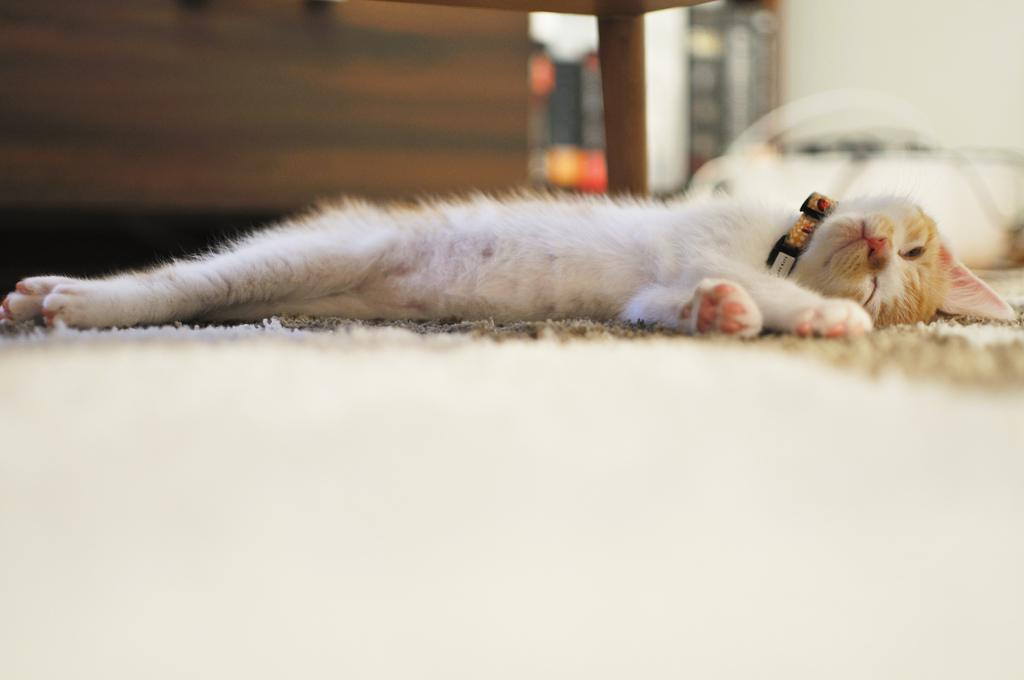What animal is present in the image? There is a cat in the image. What is the cat doing in the image? The cat is sleeping. Where is the cat located in the image? The cat is on a bed. How is the cat positioned in the image? The cat is in the center of the image. What type of cover is draped over the cat in the image? There is no cover draped over the cat in the image; the cat is sleeping on a bed without any visible cover. 